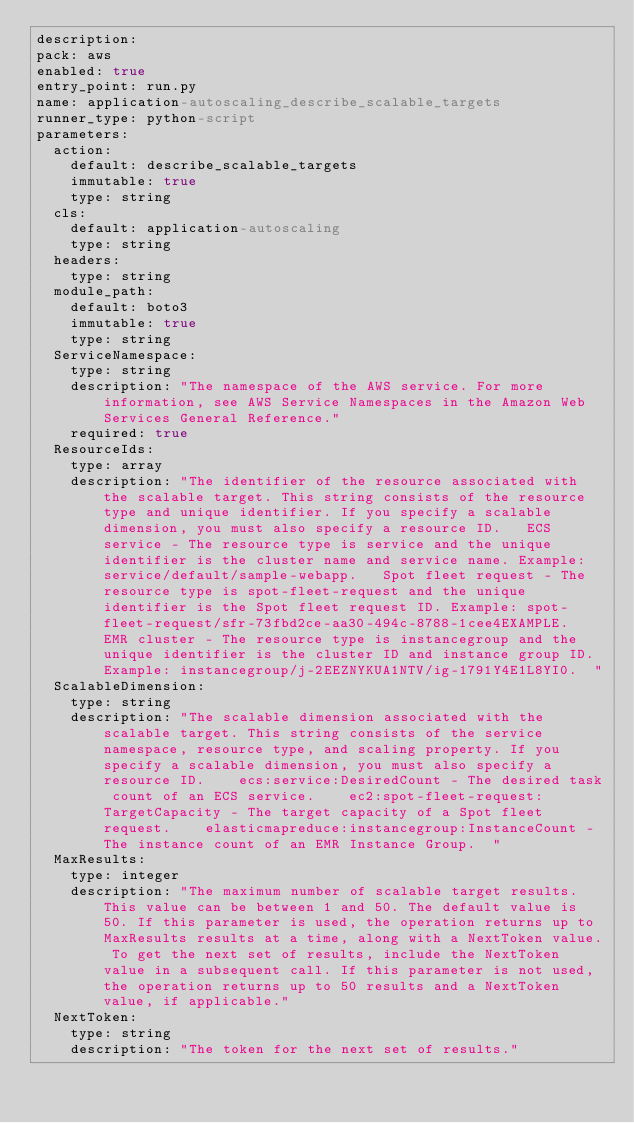Convert code to text. <code><loc_0><loc_0><loc_500><loc_500><_YAML_>description: 
pack: aws
enabled: true
entry_point: run.py
name: application-autoscaling_describe_scalable_targets
runner_type: python-script
parameters:
  action:
    default: describe_scalable_targets
    immutable: true
    type: string
  cls:
    default: application-autoscaling
    type: string
  headers:
    type: string
  module_path:
    default: boto3
    immutable: true
    type: string
  ServiceNamespace:
    type: string
    description: "The namespace of the AWS service. For more information, see AWS Service Namespaces in the Amazon Web Services General Reference."
    required: true
  ResourceIds:
    type: array
    description: "The identifier of the resource associated with the scalable target. This string consists of the resource type and unique identifier. If you specify a scalable dimension, you must also specify a resource ID.   ECS service - The resource type is service and the unique identifier is the cluster name and service name. Example: service/default/sample-webapp.   Spot fleet request - The resource type is spot-fleet-request and the unique identifier is the Spot fleet request ID. Example: spot-fleet-request/sfr-73fbd2ce-aa30-494c-8788-1cee4EXAMPLE.   EMR cluster - The resource type is instancegroup and the unique identifier is the cluster ID and instance group ID. Example: instancegroup/j-2EEZNYKUA1NTV/ig-1791Y4E1L8YI0.  "
  ScalableDimension:
    type: string
    description: "The scalable dimension associated with the scalable target. This string consists of the service namespace, resource type, and scaling property. If you specify a scalable dimension, you must also specify a resource ID.    ecs:service:DesiredCount - The desired task count of an ECS service.    ec2:spot-fleet-request:TargetCapacity - The target capacity of a Spot fleet request.    elasticmapreduce:instancegroup:InstanceCount - The instance count of an EMR Instance Group.  "
  MaxResults:
    type: integer
    description: "The maximum number of scalable target results. This value can be between 1 and 50. The default value is 50. If this parameter is used, the operation returns up to MaxResults results at a time, along with a NextToken value. To get the next set of results, include the NextToken value in a subsequent call. If this parameter is not used, the operation returns up to 50 results and a NextToken value, if applicable."
  NextToken:
    type: string
    description: "The token for the next set of results."</code> 